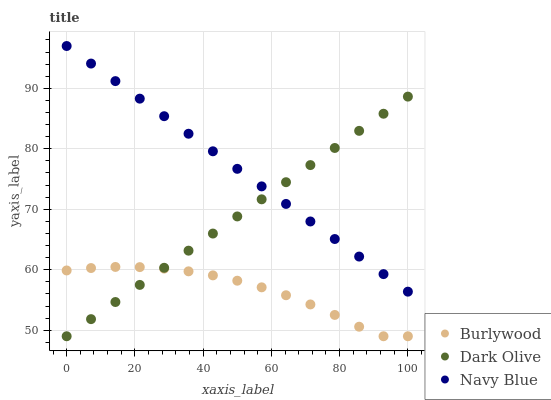Does Burlywood have the minimum area under the curve?
Answer yes or no. Yes. Does Navy Blue have the maximum area under the curve?
Answer yes or no. Yes. Does Dark Olive have the minimum area under the curve?
Answer yes or no. No. Does Dark Olive have the maximum area under the curve?
Answer yes or no. No. Is Dark Olive the smoothest?
Answer yes or no. Yes. Is Burlywood the roughest?
Answer yes or no. Yes. Is Navy Blue the smoothest?
Answer yes or no. No. Is Navy Blue the roughest?
Answer yes or no. No. Does Burlywood have the lowest value?
Answer yes or no. Yes. Does Navy Blue have the lowest value?
Answer yes or no. No. Does Navy Blue have the highest value?
Answer yes or no. Yes. Does Dark Olive have the highest value?
Answer yes or no. No. Is Burlywood less than Navy Blue?
Answer yes or no. Yes. Is Navy Blue greater than Burlywood?
Answer yes or no. Yes. Does Burlywood intersect Dark Olive?
Answer yes or no. Yes. Is Burlywood less than Dark Olive?
Answer yes or no. No. Is Burlywood greater than Dark Olive?
Answer yes or no. No. Does Burlywood intersect Navy Blue?
Answer yes or no. No. 